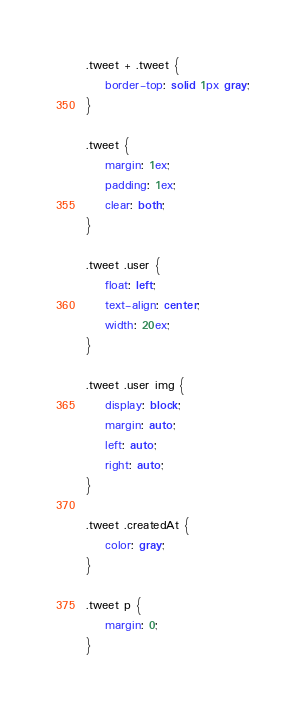Convert code to text. <code><loc_0><loc_0><loc_500><loc_500><_CSS_>.tweet + .tweet {
	border-top: solid 1px gray;
}

.tweet {
	margin: 1ex;
	padding: 1ex;
	clear: both;
}

.tweet .user {
	float: left;
	text-align: center;
	width: 20ex;
}

.tweet .user img {
	display: block;
	margin: auto;
	left: auto;
	right: auto;
}

.tweet .createdAt {
	color: gray;
}

.tweet p {
	margin: 0;
}
</code> 